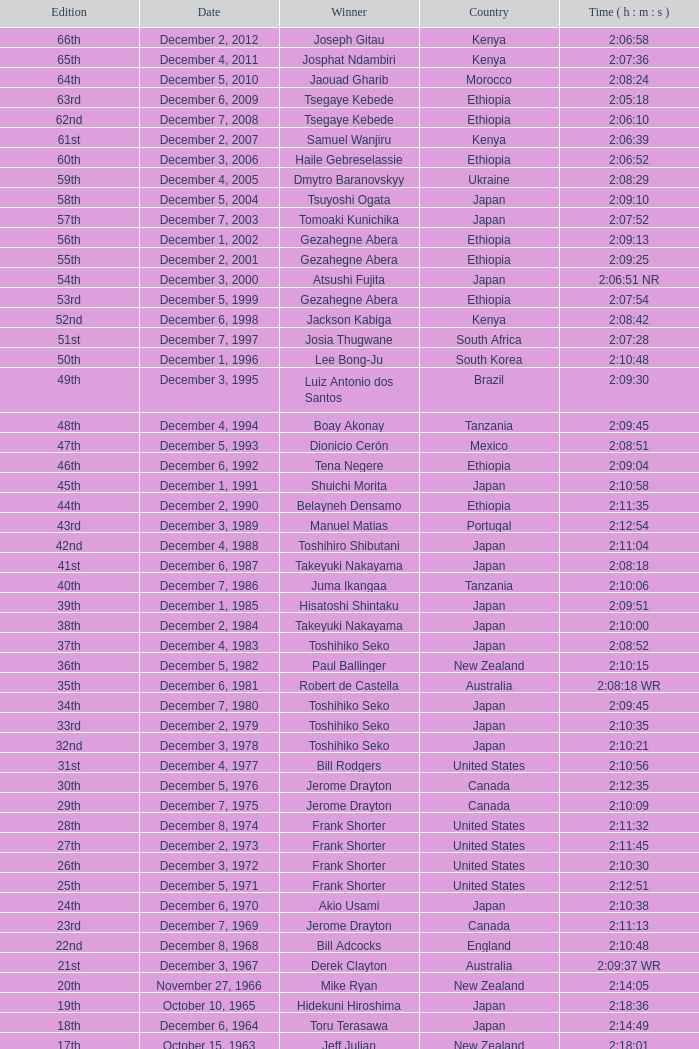The winner of the 20th edition belonged to which nationality? New Zealand. 